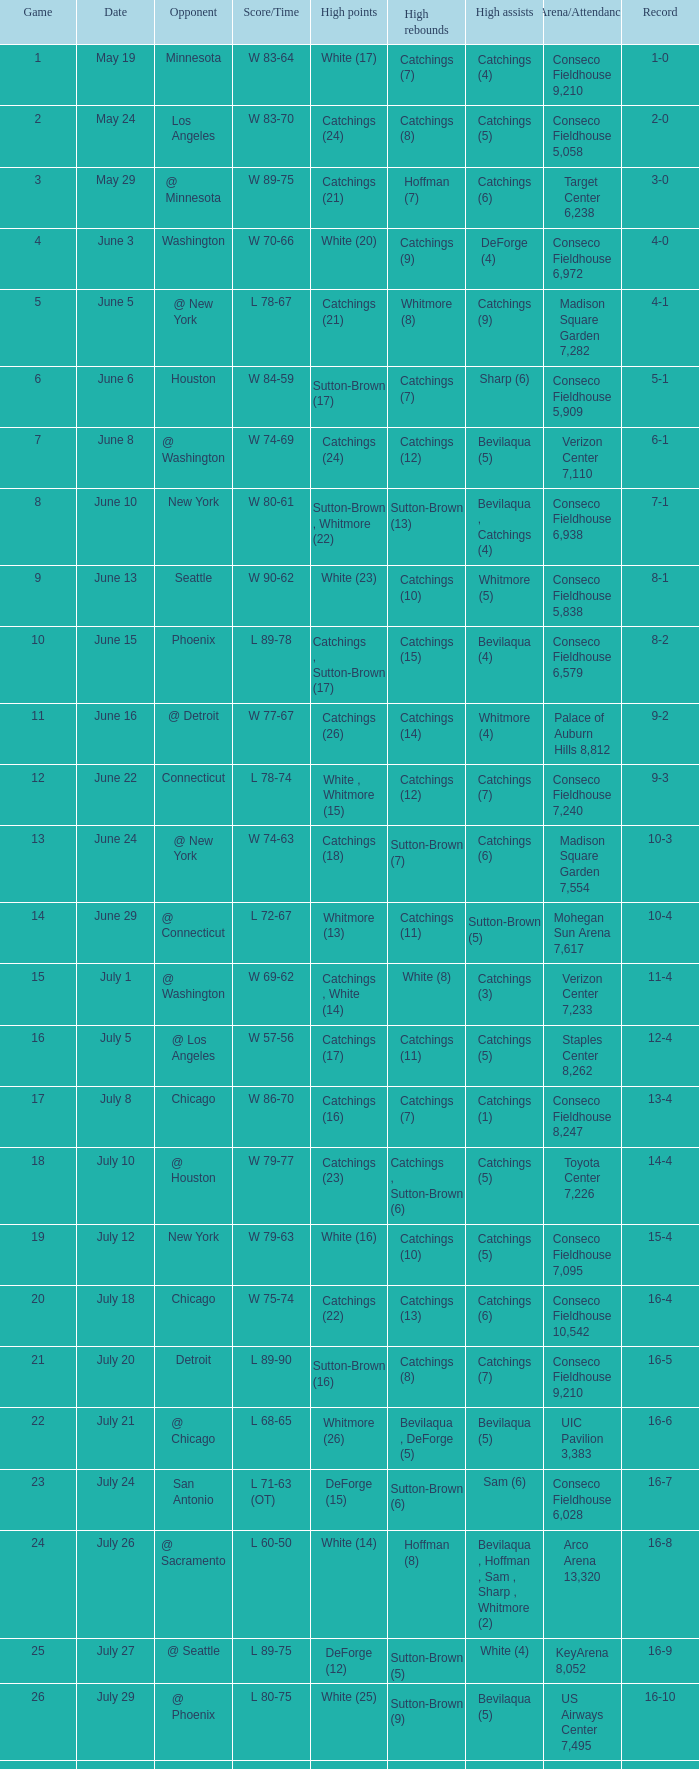Name the total number of opponent of record 9-2 1.0. 